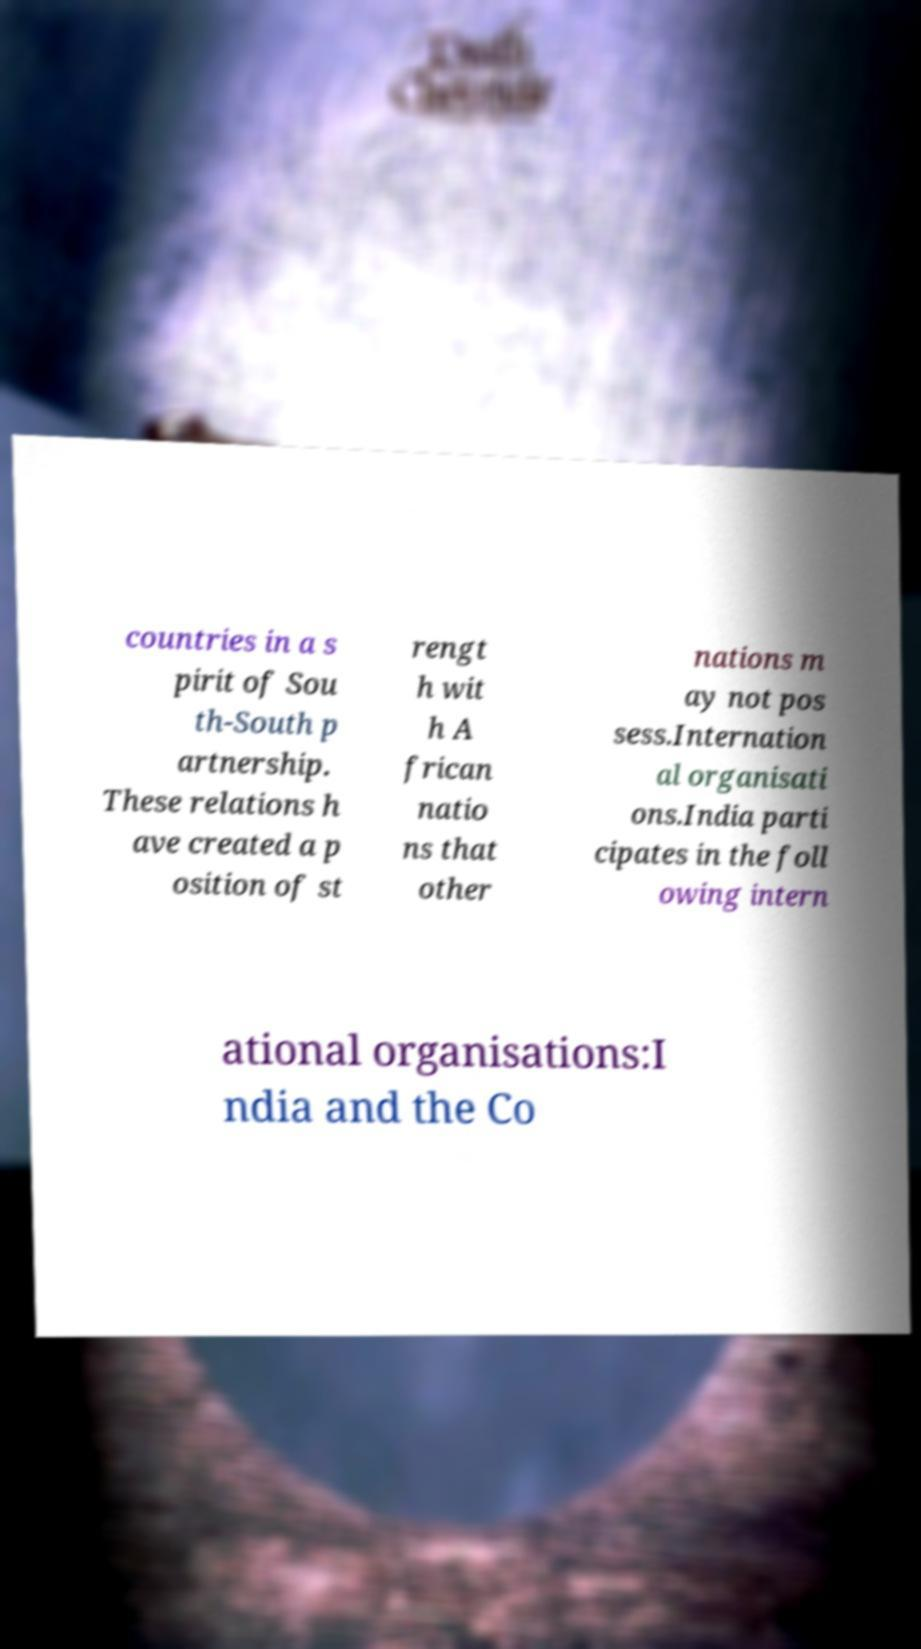Please read and relay the text visible in this image. What does it say? countries in a s pirit of Sou th-South p artnership. These relations h ave created a p osition of st rengt h wit h A frican natio ns that other nations m ay not pos sess.Internation al organisati ons.India parti cipates in the foll owing intern ational organisations:I ndia and the Co 